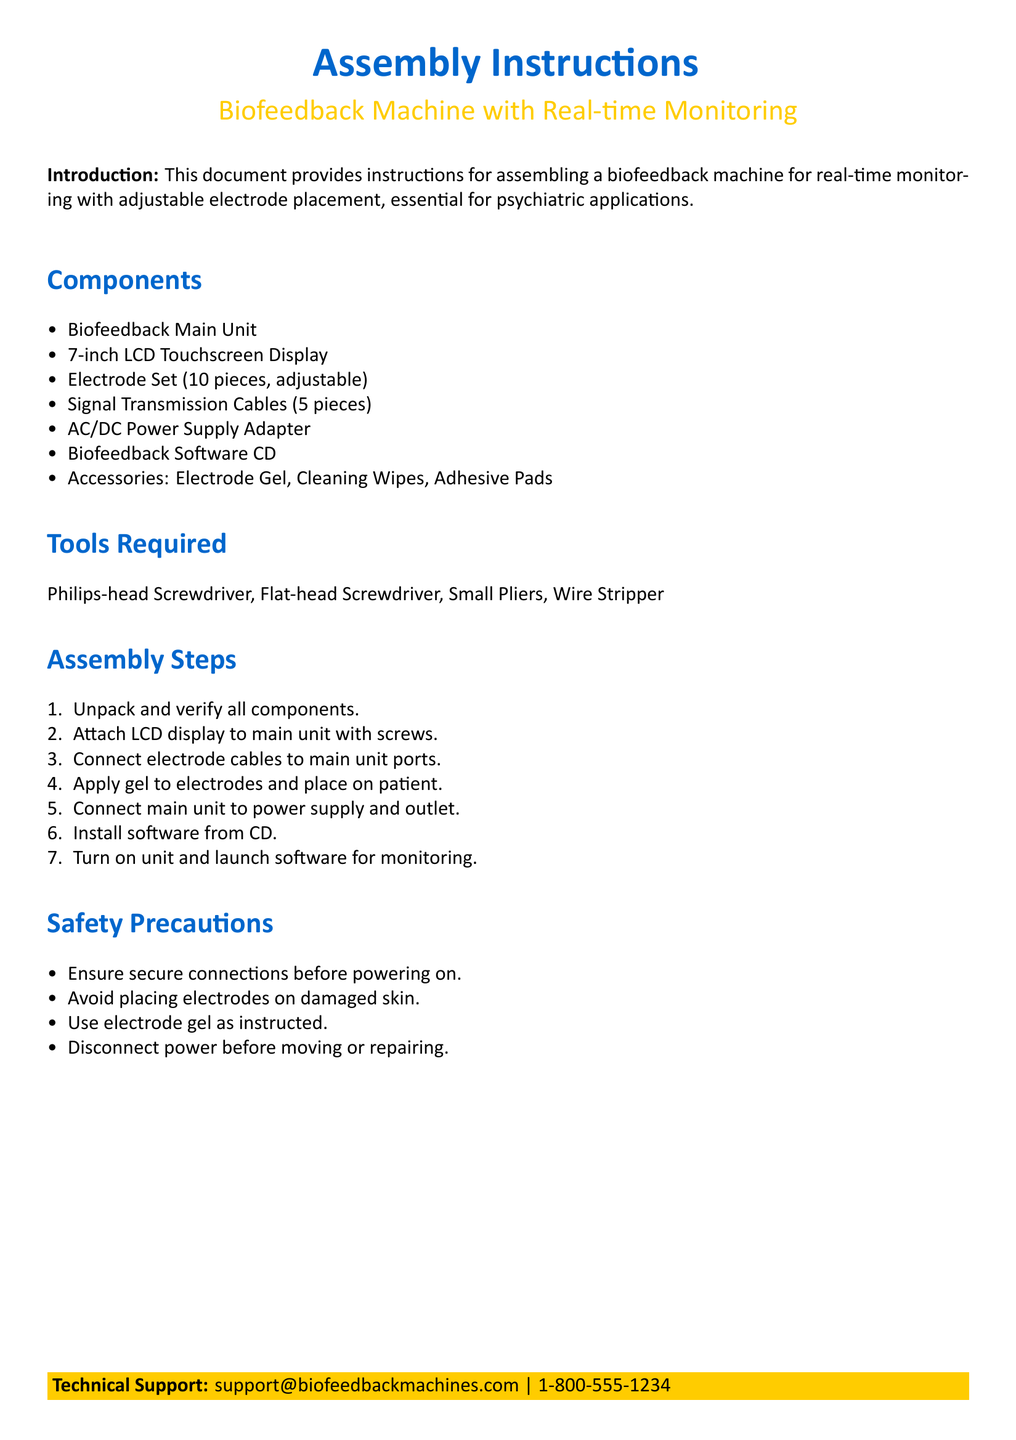what is the main purpose of this document? The main purpose of the document is to provide assembly instructions for a biofeedback machine used for real-time monitoring in psychiatric applications.
Answer: assembly instructions for a biofeedback machine with real-time monitoring how many pieces are included in the electrode set? The document specifies that the electrode set comprises 10 pieces that are adjustable.
Answer: 10 pieces what tools are required for assembly? The document lists the tools necessary for assembly, which include a Philips-head screwdriver, a Flat-head screwdriver, Small pliers, and a Wire stripper.
Answer: Philips-head Screwdriver, Flat-head Screwdriver, Small Pliers, Wire Stripper which component is used for displaying information? The document mentions a 7-inch LCD touchscreen display as the component for showing information.
Answer: 7-inch LCD Touchscreen Display what should be done before powering on the machine? The document states that secure connections should be ensured prior to turning on the machine to ensure safety.
Answer: Ensure secure connections what steps are taken to prepare the electrodes? According to the document, gel should be applied to the electrodes before placing them on the patient.
Answer: Apply gel to electrodes what is the technical support contact number? The document provides contact information for technical support, which includes a phone number.
Answer: 1-800-555-1234 how many signal transmission cables are included? The document notes that there are five signal transmission cables included in the assembly kit.
Answer: 5 pieces 